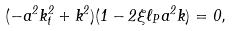<formula> <loc_0><loc_0><loc_500><loc_500>( - a ^ { 2 } k _ { t } ^ { 2 } + k ^ { 2 } ) ( 1 - 2 \xi \ell _ { P } a ^ { 2 } k ) = 0 ,</formula> 